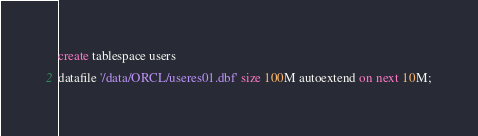<code> <loc_0><loc_0><loc_500><loc_500><_SQL_>create tablespace users
datafile '/data/ORCL/useres01.dbf' size 100M autoextend on next 10M;

</code> 